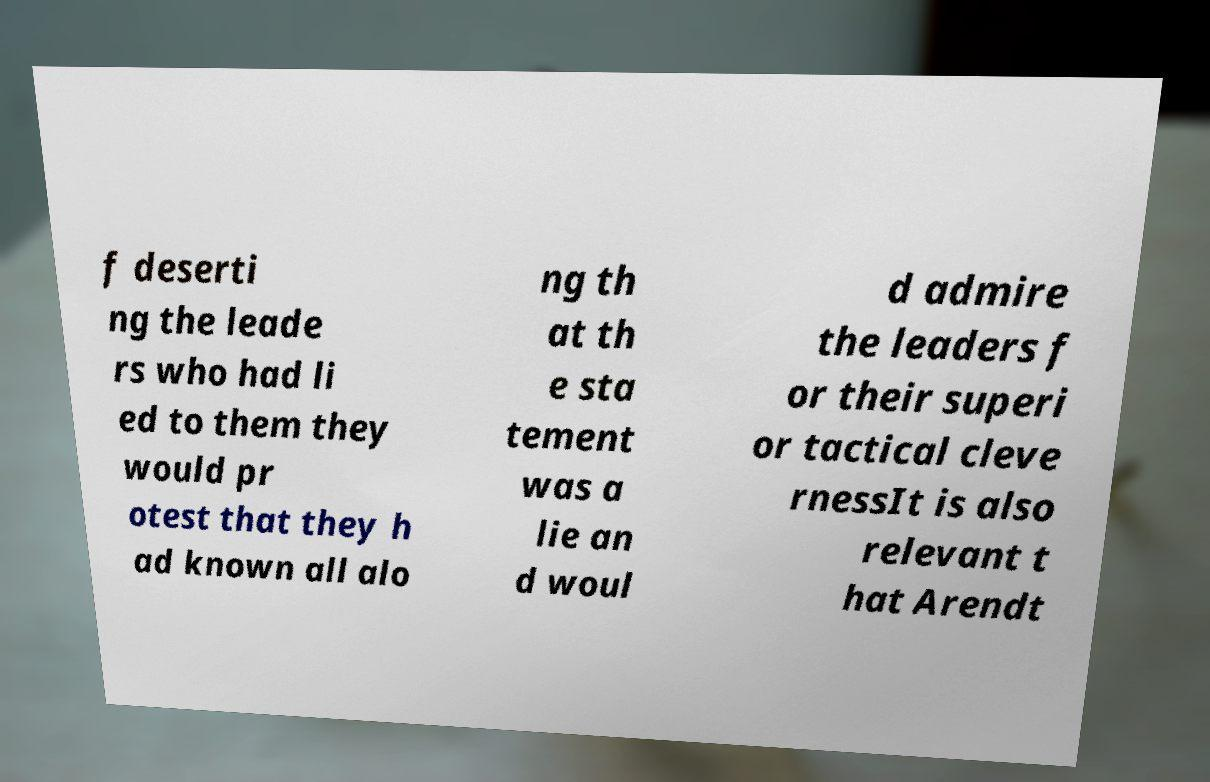Can you accurately transcribe the text from the provided image for me? f deserti ng the leade rs who had li ed to them they would pr otest that they h ad known all alo ng th at th e sta tement was a lie an d woul d admire the leaders f or their superi or tactical cleve rnessIt is also relevant t hat Arendt 